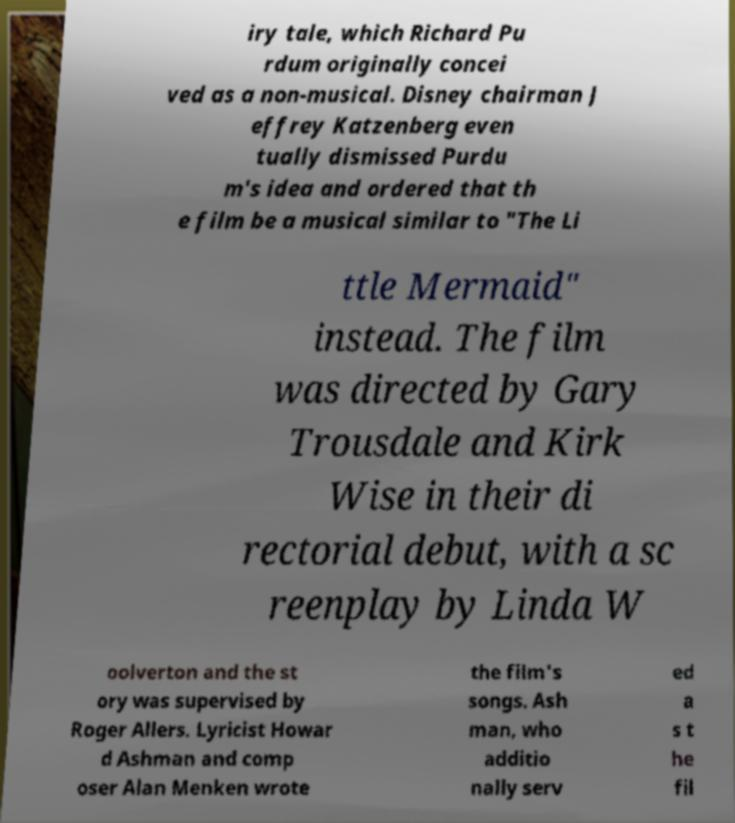There's text embedded in this image that I need extracted. Can you transcribe it verbatim? iry tale, which Richard Pu rdum originally concei ved as a non-musical. Disney chairman J effrey Katzenberg even tually dismissed Purdu m's idea and ordered that th e film be a musical similar to "The Li ttle Mermaid" instead. The film was directed by Gary Trousdale and Kirk Wise in their di rectorial debut, with a sc reenplay by Linda W oolverton and the st ory was supervised by Roger Allers. Lyricist Howar d Ashman and comp oser Alan Menken wrote the film's songs. Ash man, who additio nally serv ed a s t he fil 